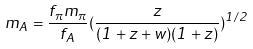Convert formula to latex. <formula><loc_0><loc_0><loc_500><loc_500>m _ { A } = \frac { f _ { \pi } m _ { \pi } } { f _ { A } } ( \frac { z } { ( 1 + z + w ) ( 1 + z ) } ) ^ { 1 / 2 }</formula> 